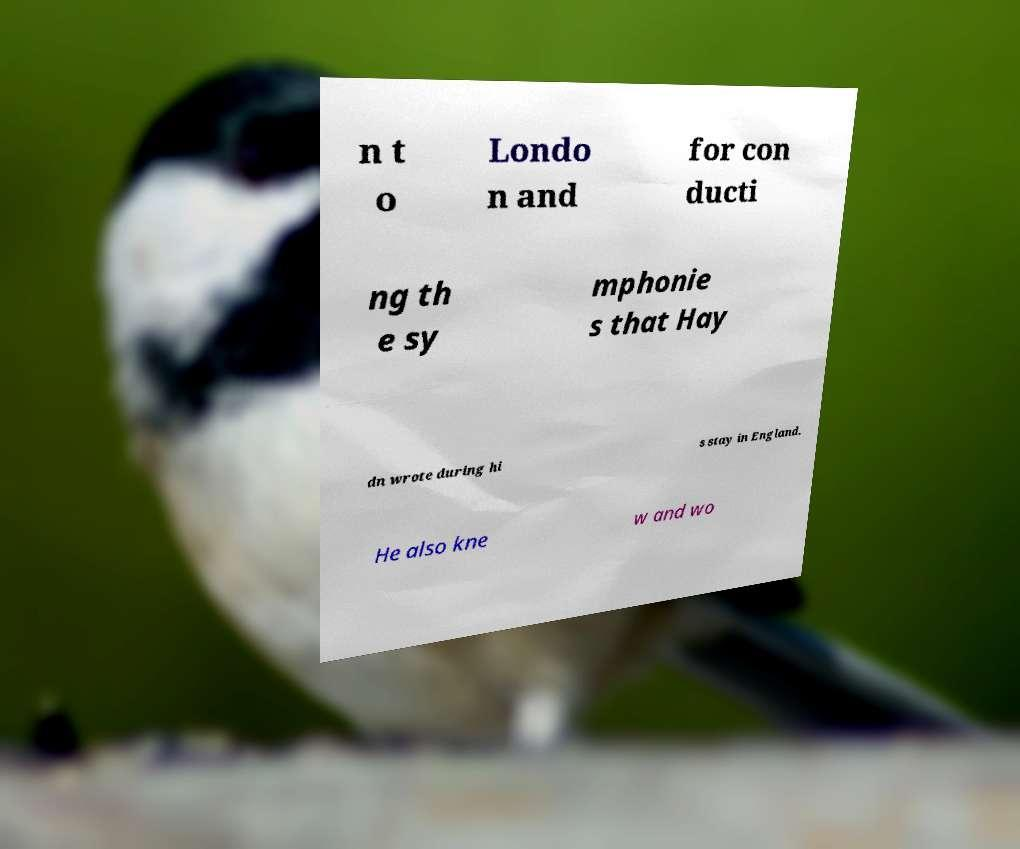What messages or text are displayed in this image? I need them in a readable, typed format. n t o Londo n and for con ducti ng th e sy mphonie s that Hay dn wrote during hi s stay in England. He also kne w and wo 